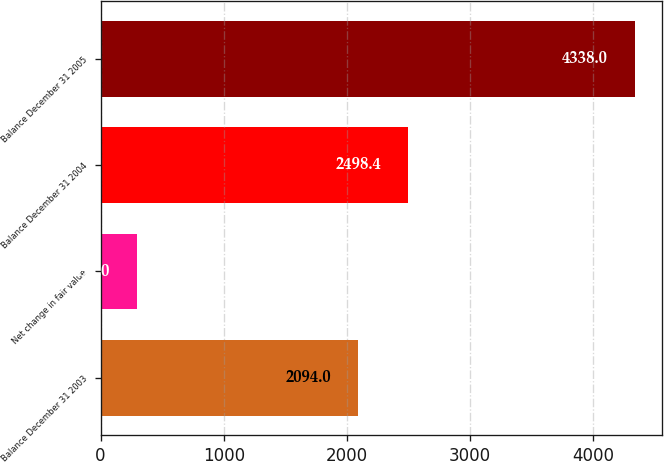<chart> <loc_0><loc_0><loc_500><loc_500><bar_chart><fcel>Balance December 31 2003<fcel>Net change in fair value<fcel>Balance December 31 2004<fcel>Balance December 31 2005<nl><fcel>2094<fcel>294<fcel>2498.4<fcel>4338<nl></chart> 